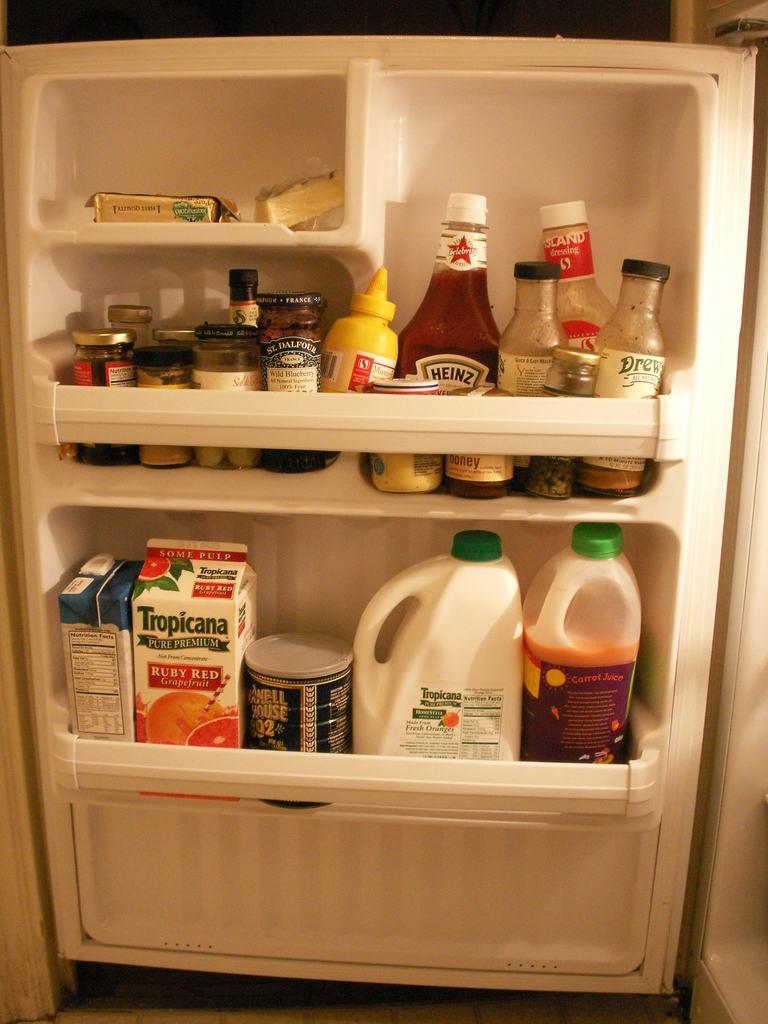<image>
Provide a brief description of the given image. A well stocked refrigerator door, with two bottles of Tropicana in it. 